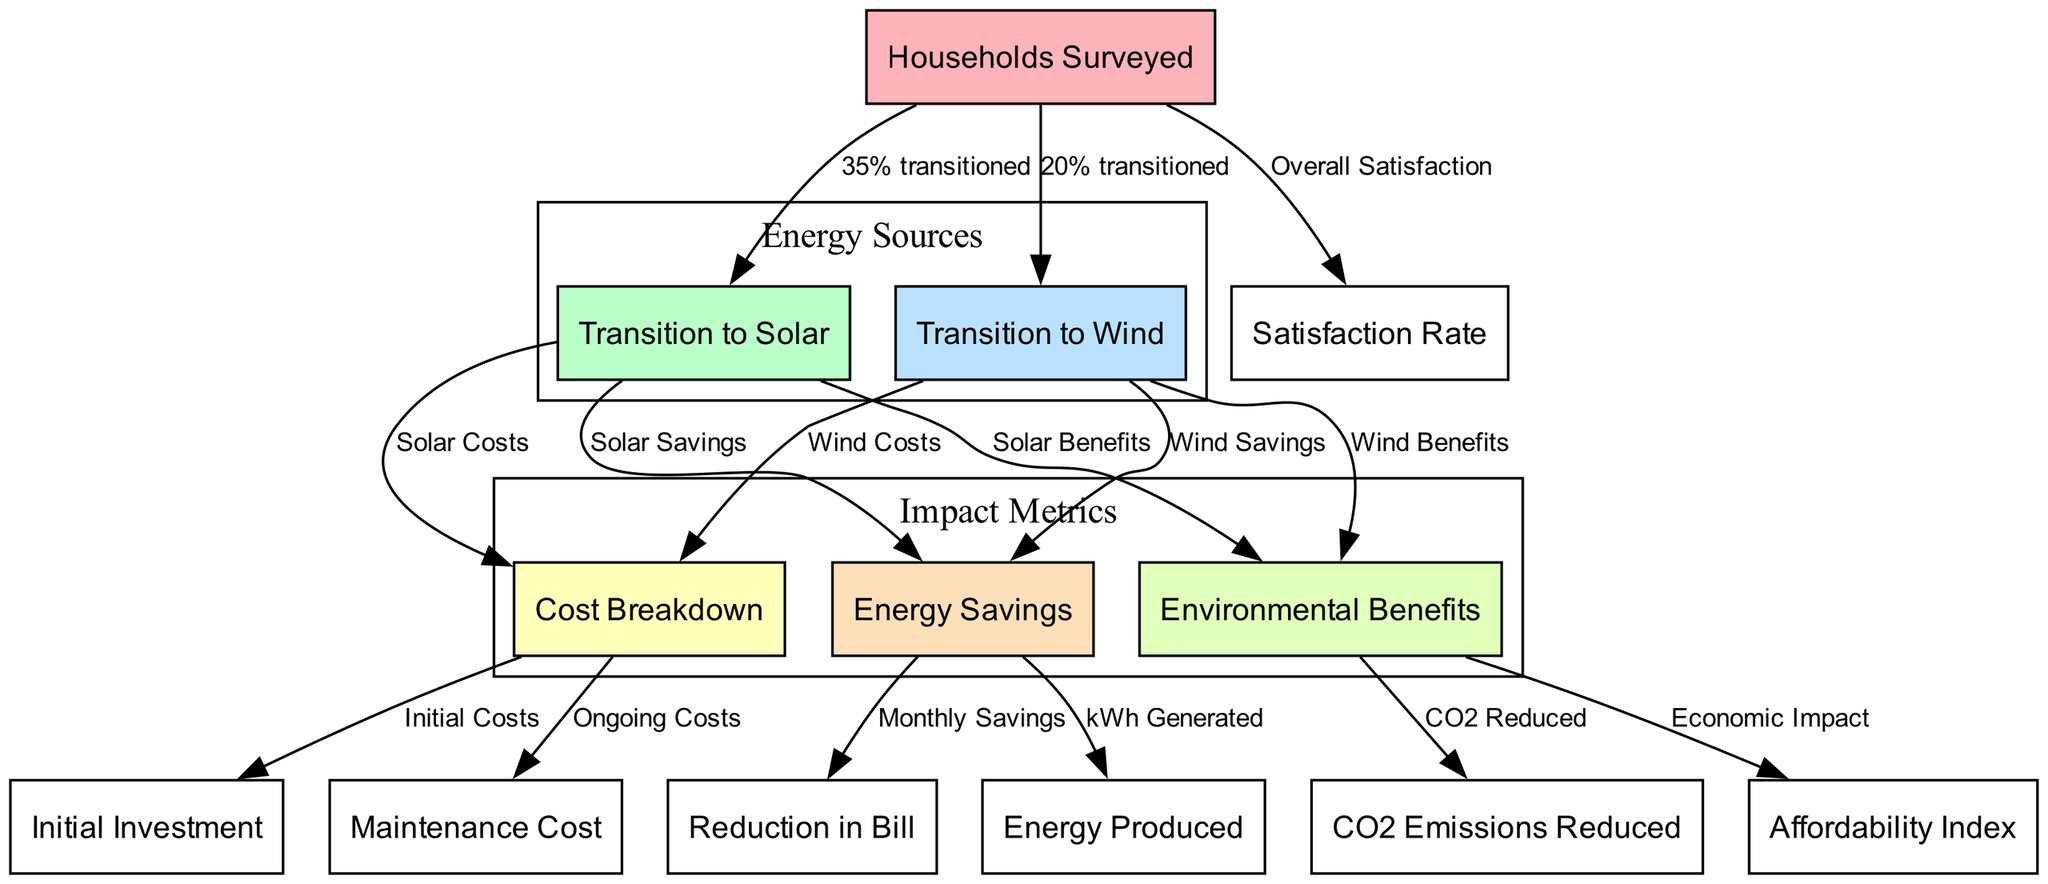What percentage of households transitioned to solar energy? The diagram indicates that 35% of the households surveyed transitioned to solar energy. To find this, we look at the edge connecting "Households Surveyed" to "Transition to Solar," which explicitly states the percentage.
Answer: 35% What is the satisfaction rate of households surveyed? The "Satisfaction Rate" is connected to the "Households Surveyed" node in the diagram. While the exact value is not specified in the given data, we conclude that there is a measurement for it since it is included in the network.
Answer: Not specified What is the cost associated with the initial investment for renewable energy? The "Cost Breakdown" node has a sub-node labeled "Initial Investment," indicating that there is a defined cost for starting the transition to renewable energy. However, the specific amount isn't provided in the diagram hence only its presence is recognized.
Answer: Not specified How do the environmental benefits relate to CO2 emissions reduction? The "Environmental Benefits" node connects directly to the "CO2 Emissions Reduced" node, indicating that one of the outcomes or metrics of environmental benefits is the reduction in carbon dioxide emissions. This relationship is highlighted by the edge labeled "CO2 Reduced."
Answer: CO2 Reduced What is the percentage of households that transitioned to wind energy? The diagram shows that 20% of households surveyed transitioned to wind energy, as indicated by the edge connecting "Households Surveyed" to "Transition to Wind." This specific value is clearly marked in the diagram.
Answer: 20% What are the ongoing costs represented in the cost breakdown? Within the "Cost Breakdown" node, there is an edge leading to the "Maintenance Cost" node. This connection indicates that ongoing costs related to maintenance are a component of the overall cost breakdown for households transitioning to renewable energy.
Answer: Maintenance Cost What is the relationship between energy savings and monthly bills? The "Energy Savings" node connects to the "Reduction in Bill" node, which indicates that the savings associated with renewable energy translate directly into reductions in monthly energy bills, showcasing how adopting these technologies impacts household finances.
Answer: Monthly Savings Which metric shows the energy produced by households? The "Energy Produced" node connects to the "Energy Savings" node, indicating that the amount of energy generated by households is a contributing factor to overall savings from renewable energy use. This relationship illustrates the connection between energy efficiency and production.
Answer: kWh Generated 